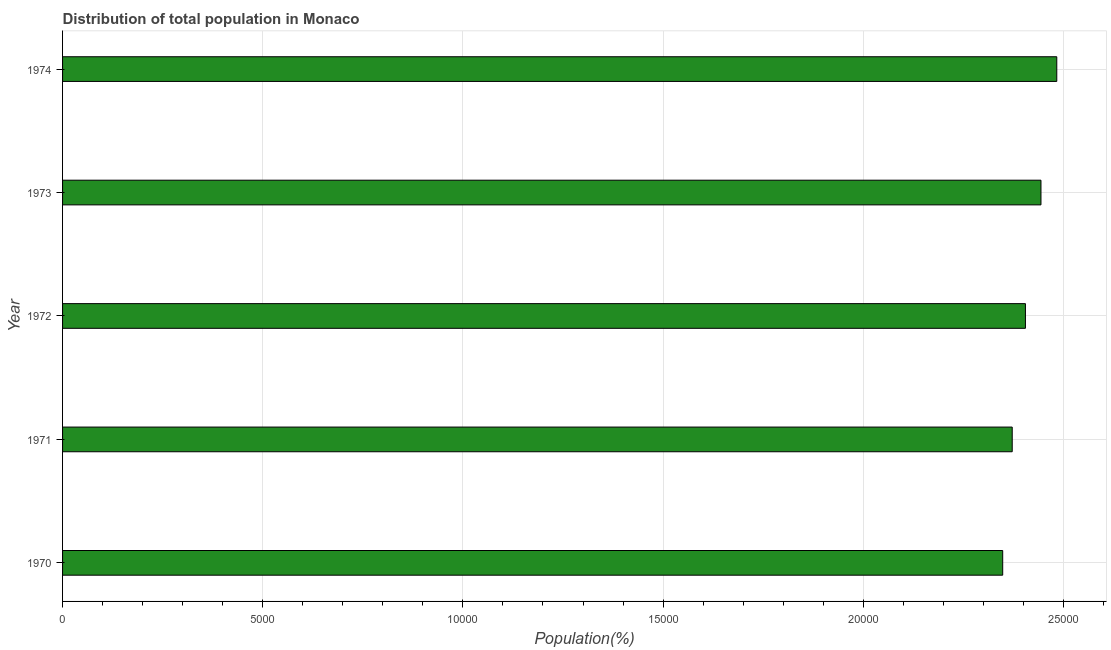What is the title of the graph?
Provide a short and direct response. Distribution of total population in Monaco . What is the label or title of the X-axis?
Your answer should be very brief. Population(%). What is the population in 1973?
Provide a succinct answer. 2.44e+04. Across all years, what is the maximum population?
Your answer should be very brief. 2.48e+04. Across all years, what is the minimum population?
Your answer should be compact. 2.35e+04. In which year was the population maximum?
Ensure brevity in your answer.  1974. What is the sum of the population?
Make the answer very short. 1.21e+05. What is the difference between the population in 1970 and 1972?
Make the answer very short. -568. What is the average population per year?
Provide a short and direct response. 2.41e+04. What is the median population?
Offer a terse response. 2.41e+04. Do a majority of the years between 1974 and 1972 (inclusive) have population greater than 5000 %?
Make the answer very short. Yes. What is the ratio of the population in 1970 to that in 1974?
Ensure brevity in your answer.  0.95. Is the population in 1971 less than that in 1973?
Your answer should be very brief. Yes. Is the difference between the population in 1970 and 1971 greater than the difference between any two years?
Offer a very short reply. No. What is the difference between the highest and the second highest population?
Provide a succinct answer. 395. What is the difference between the highest and the lowest population?
Offer a very short reply. 1351. What is the Population(%) of 1970?
Your answer should be very brief. 2.35e+04. What is the Population(%) of 1971?
Provide a succinct answer. 2.37e+04. What is the Population(%) of 1972?
Your response must be concise. 2.41e+04. What is the Population(%) of 1973?
Provide a succinct answer. 2.44e+04. What is the Population(%) of 1974?
Provide a succinct answer. 2.48e+04. What is the difference between the Population(%) in 1970 and 1971?
Provide a short and direct response. -238. What is the difference between the Population(%) in 1970 and 1972?
Make the answer very short. -568. What is the difference between the Population(%) in 1970 and 1973?
Provide a succinct answer. -956. What is the difference between the Population(%) in 1970 and 1974?
Provide a succinct answer. -1351. What is the difference between the Population(%) in 1971 and 1972?
Your answer should be compact. -330. What is the difference between the Population(%) in 1971 and 1973?
Your answer should be very brief. -718. What is the difference between the Population(%) in 1971 and 1974?
Provide a succinct answer. -1113. What is the difference between the Population(%) in 1972 and 1973?
Keep it short and to the point. -388. What is the difference between the Population(%) in 1972 and 1974?
Offer a very short reply. -783. What is the difference between the Population(%) in 1973 and 1974?
Provide a succinct answer. -395. What is the ratio of the Population(%) in 1970 to that in 1971?
Ensure brevity in your answer.  0.99. What is the ratio of the Population(%) in 1970 to that in 1973?
Offer a terse response. 0.96. What is the ratio of the Population(%) in 1970 to that in 1974?
Provide a succinct answer. 0.95. What is the ratio of the Population(%) in 1971 to that in 1973?
Ensure brevity in your answer.  0.97. What is the ratio of the Population(%) in 1971 to that in 1974?
Ensure brevity in your answer.  0.95. What is the ratio of the Population(%) in 1972 to that in 1973?
Provide a succinct answer. 0.98. What is the ratio of the Population(%) in 1972 to that in 1974?
Ensure brevity in your answer.  0.97. 